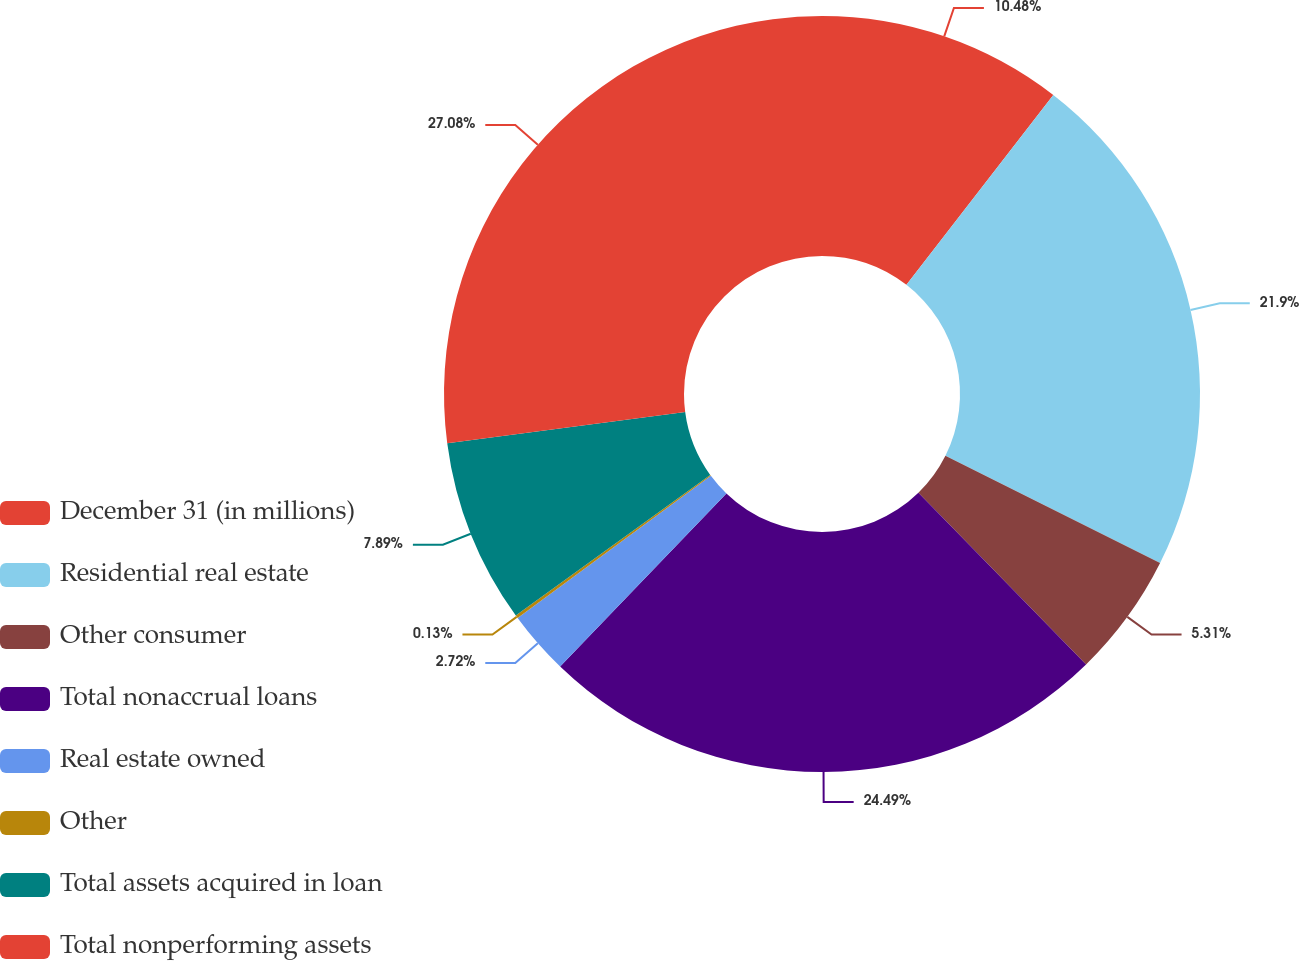<chart> <loc_0><loc_0><loc_500><loc_500><pie_chart><fcel>December 31 (in millions)<fcel>Residential real estate<fcel>Other consumer<fcel>Total nonaccrual loans<fcel>Real estate owned<fcel>Other<fcel>Total assets acquired in loan<fcel>Total nonperforming assets<nl><fcel>10.48%<fcel>21.9%<fcel>5.31%<fcel>24.49%<fcel>2.72%<fcel>0.13%<fcel>7.89%<fcel>27.08%<nl></chart> 